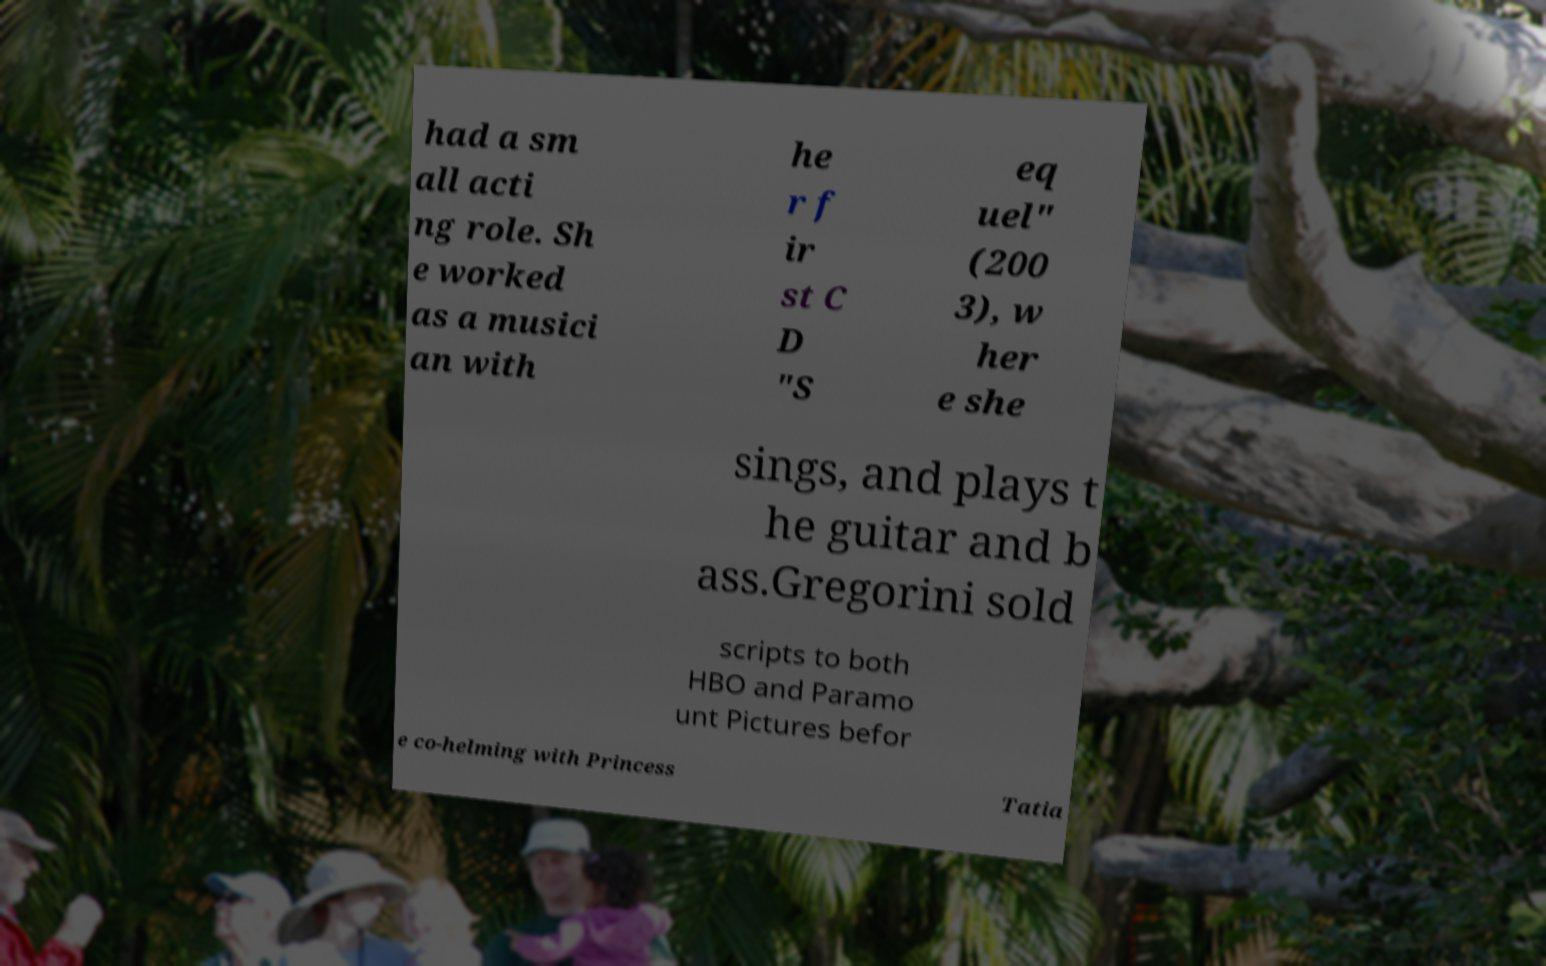Can you read and provide the text displayed in the image?This photo seems to have some interesting text. Can you extract and type it out for me? had a sm all acti ng role. Sh e worked as a musici an with he r f ir st C D "S eq uel" (200 3), w her e she sings, and plays t he guitar and b ass.Gregorini sold scripts to both HBO and Paramo unt Pictures befor e co-helming with Princess Tatia 